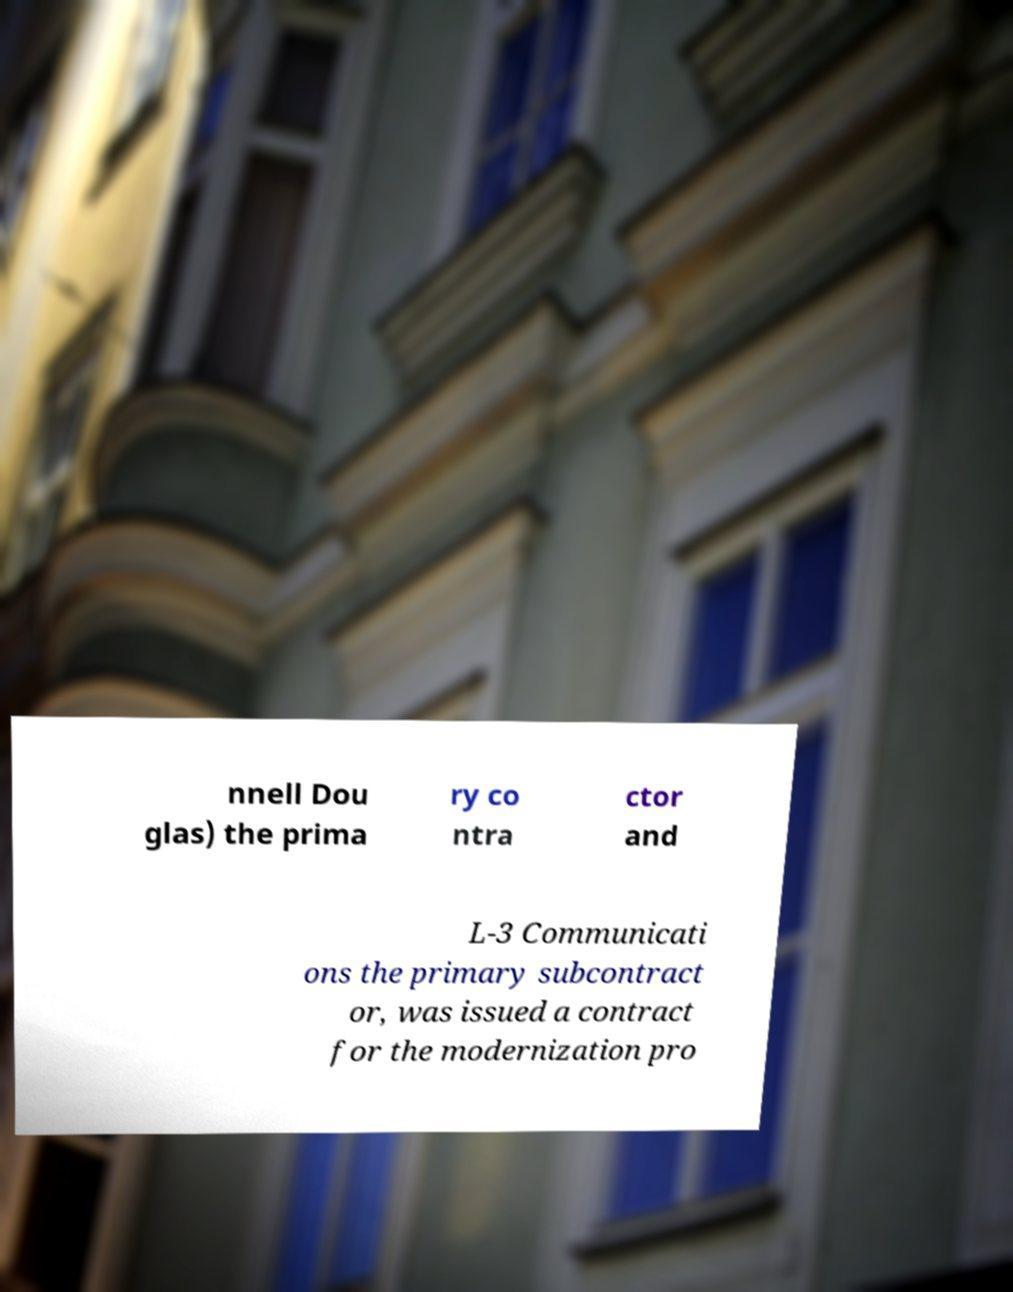Can you read and provide the text displayed in the image?This photo seems to have some interesting text. Can you extract and type it out for me? nnell Dou glas) the prima ry co ntra ctor and L-3 Communicati ons the primary subcontract or, was issued a contract for the modernization pro 